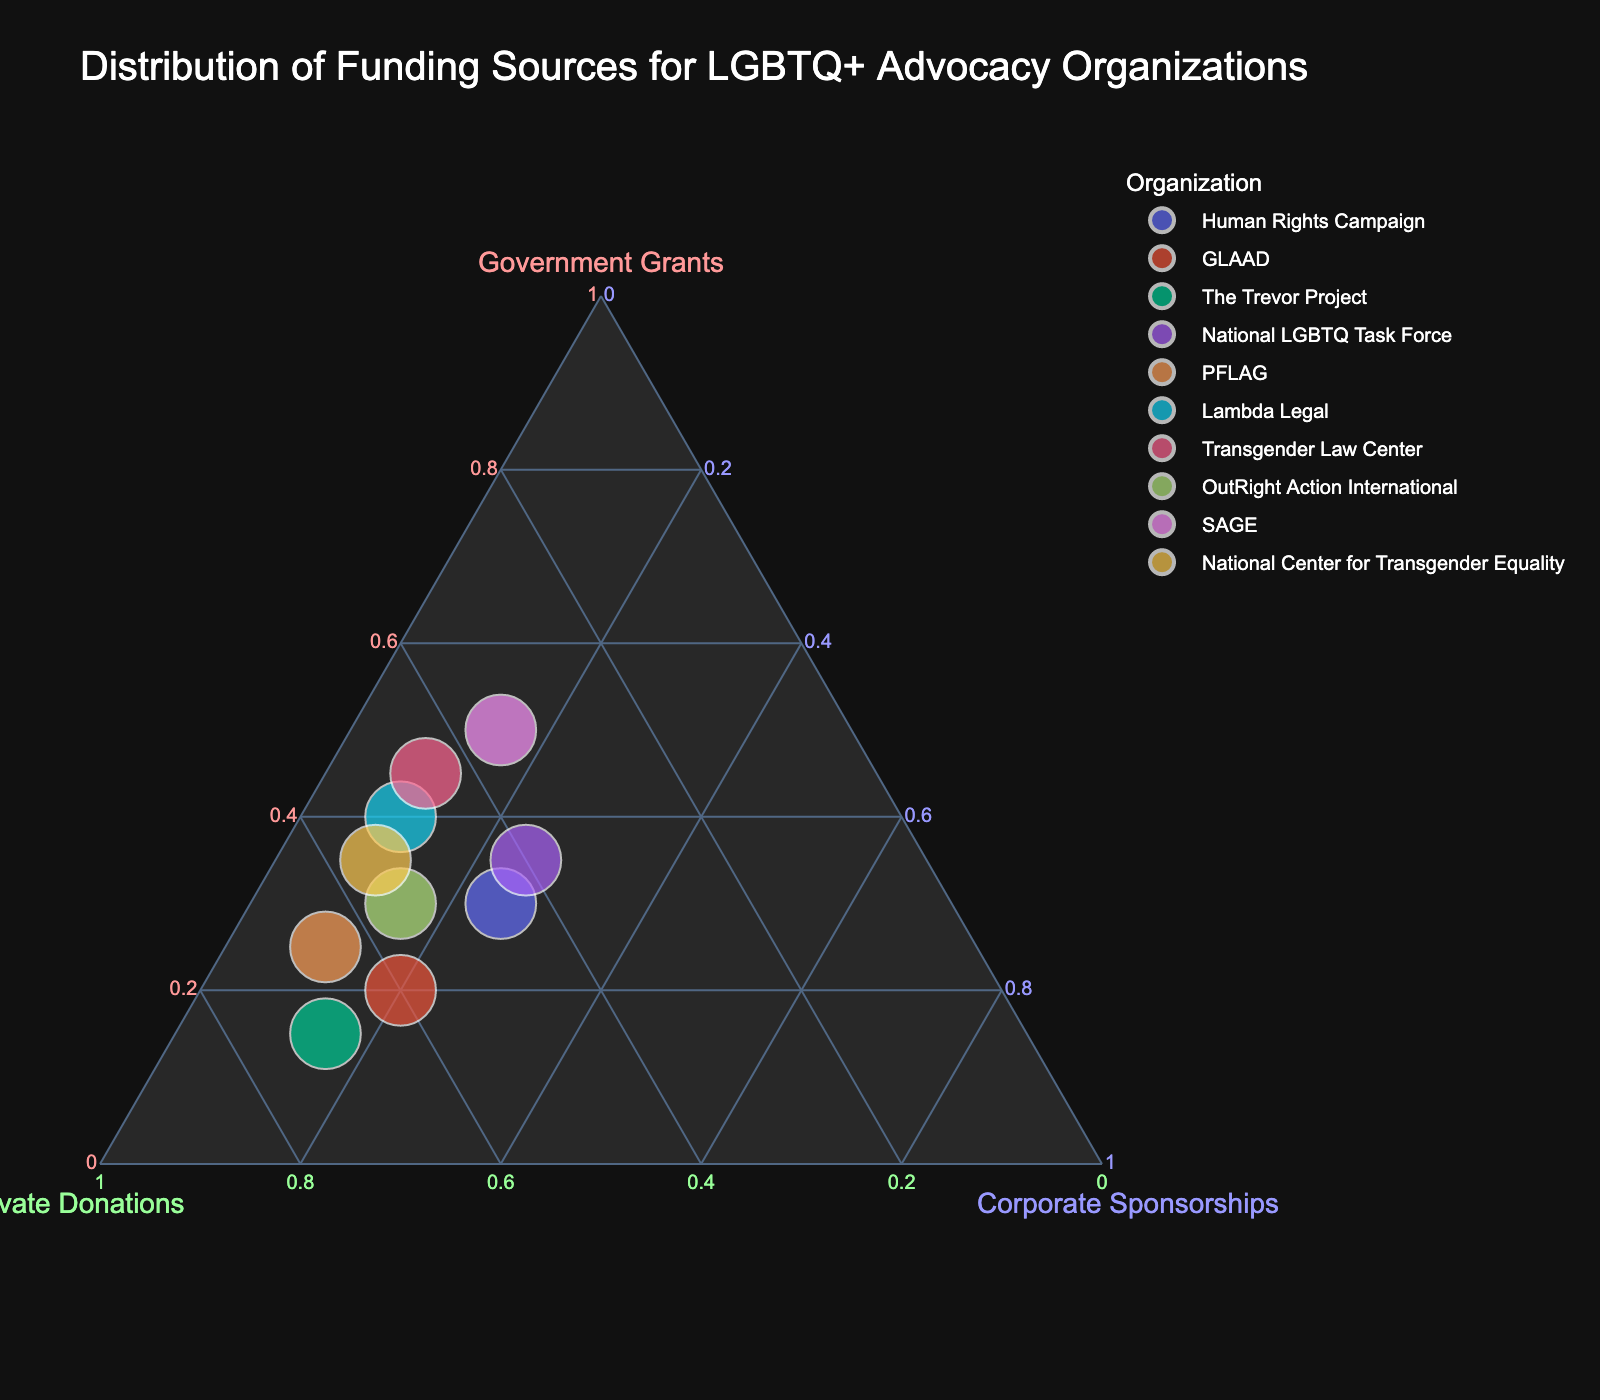What is the title of this ternary plot? The title is located at the top of the plot and usually summarizes the content or purpose of the graph. In this case, the title clearly states the subject of the graph.
Answer: Distribution of Funding Sources for LGBTQ+ Advocacy Organizations Which organization has the highest percentage of government grants? By analyzing the plot, the position closest to the "Government Grants" axis corner indicates a higher value in that category. The organization closest to this corner has the highest percentage.
Answer: SAGE How many organizations received 50% or more of their funding from private donations? Look at the ternary plot near the "Private Donations" axis for points that are at 50% or above. Count the number of points that fall within this range.
Answer: Four organizations Which organization has the most balanced funding between the three sources? The balance point would be roughly near the center of the ternary plot where percentages of the three funding sources are similar. Observe which organization is closest to this central area.
Answer: Human Rights Campaign What is the rank order of organizations from highest to lowest percentage of corporate sponsorships? Find the position of each organization relative to the "Corporate Sponsorships" axis. List the organizations in order from the one closest to this axis corner to the farthest.
Answer: Human Rights Campaign = GLAAD > The Trevor Project = OutRight Action International > PFLAG > Lambda Legal = Transgender Law Center = National Center for Transgender Equality = SAGE > National LGBTQ Task Force Which organizations have government grants as their predominant funding source? Look for organizations whose points are closest to the "Government Grants" axis, indicating that this category comprises the majority of their funding.
Answer: Lambda Legal, Transgender Law Center, SAGE Are there any organizations that do not rely on corporate sponsorships at all? If any organization's point lies on the line opposite the "Corporate Sponsorships" corner, it indicates a 0% value in that category.
Answer: None Which organization relies the most on private donations? The organization closest to the "Private Donations" axis corner will have the highest percentage in this funding source. Observe the point nearest this corner.
Answer: The Trevor Project Consider the organization Transgender Law Center. How does its funding composition compare to the average of all other organizations? Calculate the average percentage for each source (Government Grants, Private Donations, Corporate Sponsorships) for all other organizations, then compare these averages with the percentages for the Transgender Law Center.
Answer: Transgender Law Center: GG 45%, PD 45%, CS 10%; Average: Calculate all others' averages and compare 